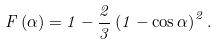Convert formula to latex. <formula><loc_0><loc_0><loc_500><loc_500>F \left ( \alpha \right ) = 1 - \frac { 2 } { 3 } \left ( 1 - \cos \alpha \right ) ^ { 2 } .</formula> 